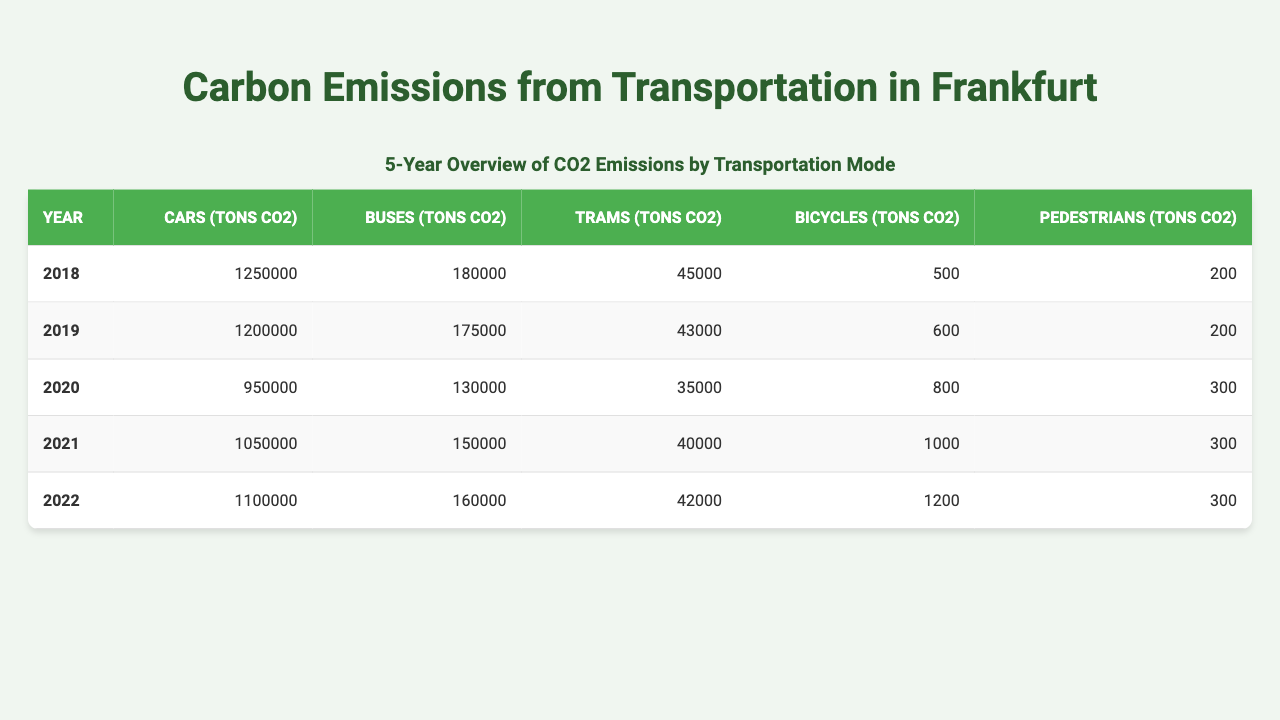What were the carbon emissions from cars in 2020? In the table under the "Cars (tons CO2)" column for the year 2020, the value is listed as 950,000 tons CO2.
Answer: 950,000 tons CO2 Which mode of transportation had the highest carbon emissions in 2019? Looking at the emissions for each transportation mode for 2019, cars emitted 1,200,000 tons CO2, which is higher than buses (175,000), trams (43,000), bicycles (600), and pedestrians (200).
Answer: Cars What is the total carbon emissions from buses over the last 5 years? By summing the values from the "Buses (tons CO2)" column for each year: 180,000 + 175,000 + 130,000 + 150,000 + 160,000 = 895,000 tons CO2.
Answer: 895,000 tons CO2 Did bicycle emissions increase every year from 2018 to 2022? The emissions from bicycles were 500 tons CO2 in 2018, then 600 in 2019, 800 in 2020, 1000 in 2021, and 1200 in 2022, which shows a steady increase each year.
Answer: Yes What was the average carbon emissions from trams over the last 5 years? The sum of tram emissions from 2018 to 2022 is 45,000 + 43,000 + 35,000 + 40,000 + 42,000 = 205,000 tons CO2. There are 5 data points, so the average is 205,000 / 5 = 41,000 tons CO2.
Answer: 41,000 tons CO2 Which year saw the lowest carbon emissions from cars? By identifying the values for cars across the years, we see 1,250,000 in 2018, 1,200,000 in 2019, 950,000 in 2020, 1,050,000 in 2021, and 1,100,000 in 2022. The lowest is 950,000 in 2020.
Answer: 2020 What was the increase in pedestrian emissions from 2018 to 2022? The emissions in 2018 were 200 tons CO2 and in 2022 they were 300 tons CO2. The difference is 300 - 200 = 100 tons CO2 increase.
Answer: 100 tons CO2 In which year did buses emit 150,000 tons CO2? Reviewing the values for buses, we see that in the year 2021, the emissions were 150,000 tons CO2.
Answer: 2021 What percentage of total carbon emissions from bicycles and pedestrians combined was accounted for by bicycles in 2021? In 2021, bicycles emitted 1,000 tons CO2 and pedestrians emitted 300 tons CO2. The total for both is 1,000 + 300 = 1,300 tons CO2. The percentage of bicycles is (1,000 / 1,300) * 100 = 76.92%.
Answer: 76.92% Which mode has consistently increased emissions every year from 2018 to 2022? Analyzing each mode, bicycles have emissions of 500, 600, 800, 1,000, and 1,200 tons CO2, showing a consistent increase every year, while others do not follow that trend.
Answer: Bicycles 